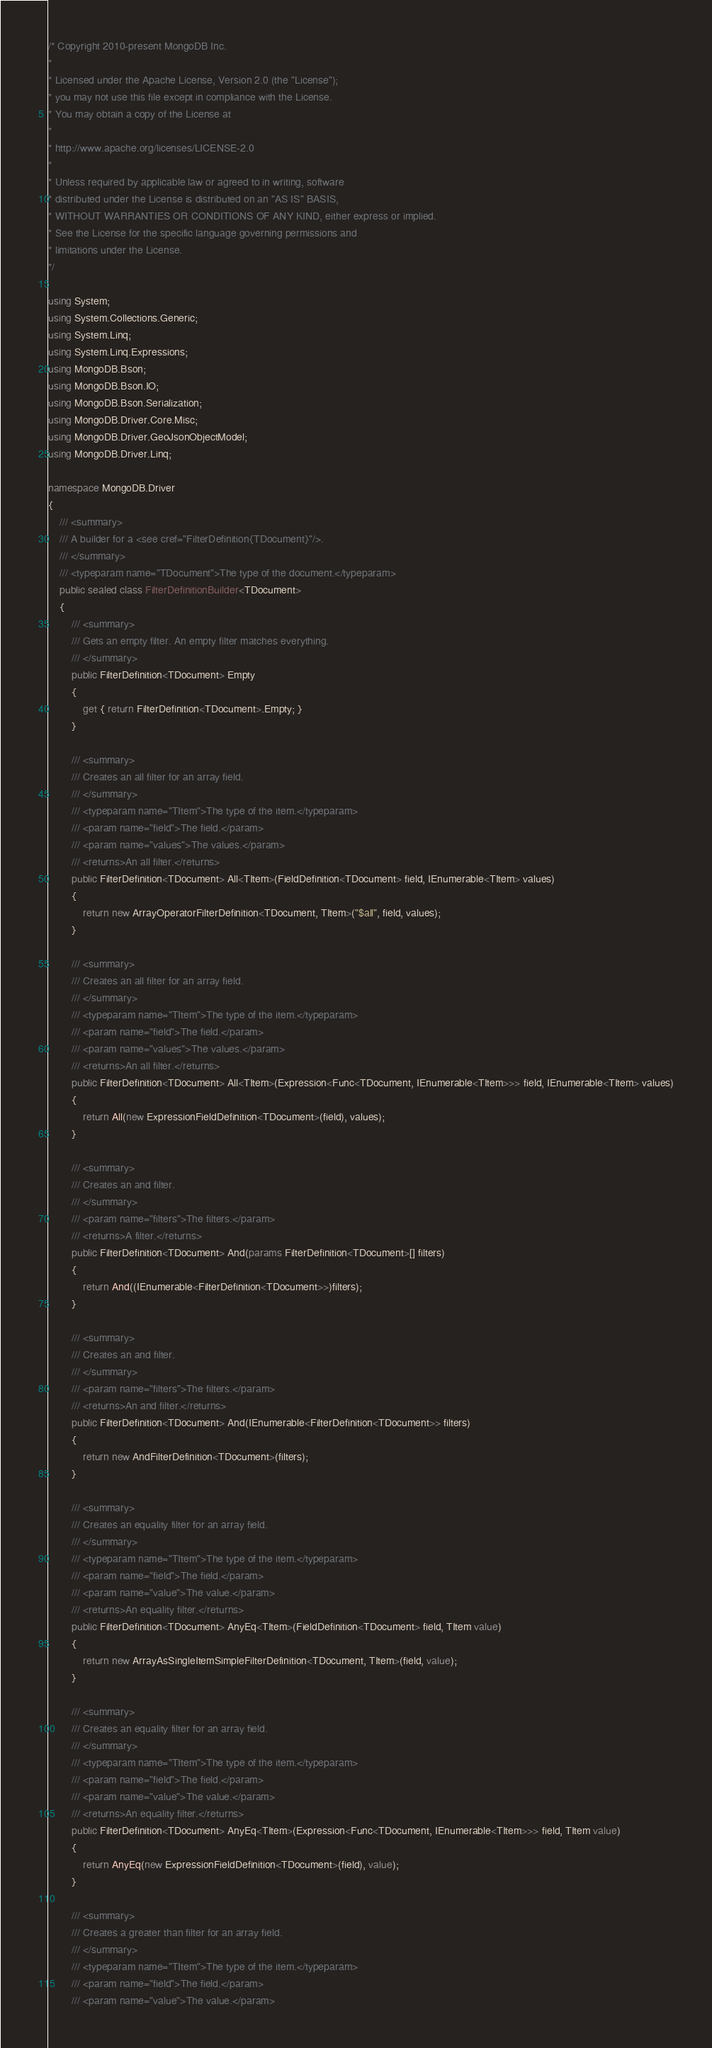<code> <loc_0><loc_0><loc_500><loc_500><_C#_>/* Copyright 2010-present MongoDB Inc.
*
* Licensed under the Apache License, Version 2.0 (the "License");
* you may not use this file except in compliance with the License.
* You may obtain a copy of the License at
*
* http://www.apache.org/licenses/LICENSE-2.0
*
* Unless required by applicable law or agreed to in writing, software
* distributed under the License is distributed on an "AS IS" BASIS,
* WITHOUT WARRANTIES OR CONDITIONS OF ANY KIND, either express or implied.
* See the License for the specific language governing permissions and
* limitations under the License.
*/

using System;
using System.Collections.Generic;
using System.Linq;
using System.Linq.Expressions;
using MongoDB.Bson;
using MongoDB.Bson.IO;
using MongoDB.Bson.Serialization;
using MongoDB.Driver.Core.Misc;
using MongoDB.Driver.GeoJsonObjectModel;
using MongoDB.Driver.Linq;

namespace MongoDB.Driver
{
    /// <summary>
    /// A builder for a <see cref="FilterDefinition{TDocument}"/>.
    /// </summary>
    /// <typeparam name="TDocument">The type of the document.</typeparam>
    public sealed class FilterDefinitionBuilder<TDocument>
    {
        /// <summary>
        /// Gets an empty filter. An empty filter matches everything.
        /// </summary>
        public FilterDefinition<TDocument> Empty
        {
            get { return FilterDefinition<TDocument>.Empty; }
        }

        /// <summary>
        /// Creates an all filter for an array field.
        /// </summary>
        /// <typeparam name="TItem">The type of the item.</typeparam>
        /// <param name="field">The field.</param>
        /// <param name="values">The values.</param>
        /// <returns>An all filter.</returns>
        public FilterDefinition<TDocument> All<TItem>(FieldDefinition<TDocument> field, IEnumerable<TItem> values)
        {
            return new ArrayOperatorFilterDefinition<TDocument, TItem>("$all", field, values);
        }

        /// <summary>
        /// Creates an all filter for an array field.
        /// </summary>
        /// <typeparam name="TItem">The type of the item.</typeparam>
        /// <param name="field">The field.</param>
        /// <param name="values">The values.</param>
        /// <returns>An all filter.</returns>
        public FilterDefinition<TDocument> All<TItem>(Expression<Func<TDocument, IEnumerable<TItem>>> field, IEnumerable<TItem> values)
        {
            return All(new ExpressionFieldDefinition<TDocument>(field), values);
        }

        /// <summary>
        /// Creates an and filter.
        /// </summary>
        /// <param name="filters">The filters.</param>
        /// <returns>A filter.</returns>
        public FilterDefinition<TDocument> And(params FilterDefinition<TDocument>[] filters)
        {
            return And((IEnumerable<FilterDefinition<TDocument>>)filters);
        }

        /// <summary>
        /// Creates an and filter.
        /// </summary>
        /// <param name="filters">The filters.</param>
        /// <returns>An and filter.</returns>
        public FilterDefinition<TDocument> And(IEnumerable<FilterDefinition<TDocument>> filters)
        {
            return new AndFilterDefinition<TDocument>(filters);
        }

        /// <summary>
        /// Creates an equality filter for an array field.
        /// </summary>
        /// <typeparam name="TItem">The type of the item.</typeparam>
        /// <param name="field">The field.</param>
        /// <param name="value">The value.</param>
        /// <returns>An equality filter.</returns>
        public FilterDefinition<TDocument> AnyEq<TItem>(FieldDefinition<TDocument> field, TItem value)
        {
            return new ArrayAsSingleItemSimpleFilterDefinition<TDocument, TItem>(field, value);
        }

        /// <summary>
        /// Creates an equality filter for an array field.
        /// </summary>
        /// <typeparam name="TItem">The type of the item.</typeparam>
        /// <param name="field">The field.</param>
        /// <param name="value">The value.</param>
        /// <returns>An equality filter.</returns>
        public FilterDefinition<TDocument> AnyEq<TItem>(Expression<Func<TDocument, IEnumerable<TItem>>> field, TItem value)
        {
            return AnyEq(new ExpressionFieldDefinition<TDocument>(field), value);
        }

        /// <summary>
        /// Creates a greater than filter for an array field.
        /// </summary>
        /// <typeparam name="TItem">The type of the item.</typeparam>
        /// <param name="field">The field.</param>
        /// <param name="value">The value.</param></code> 